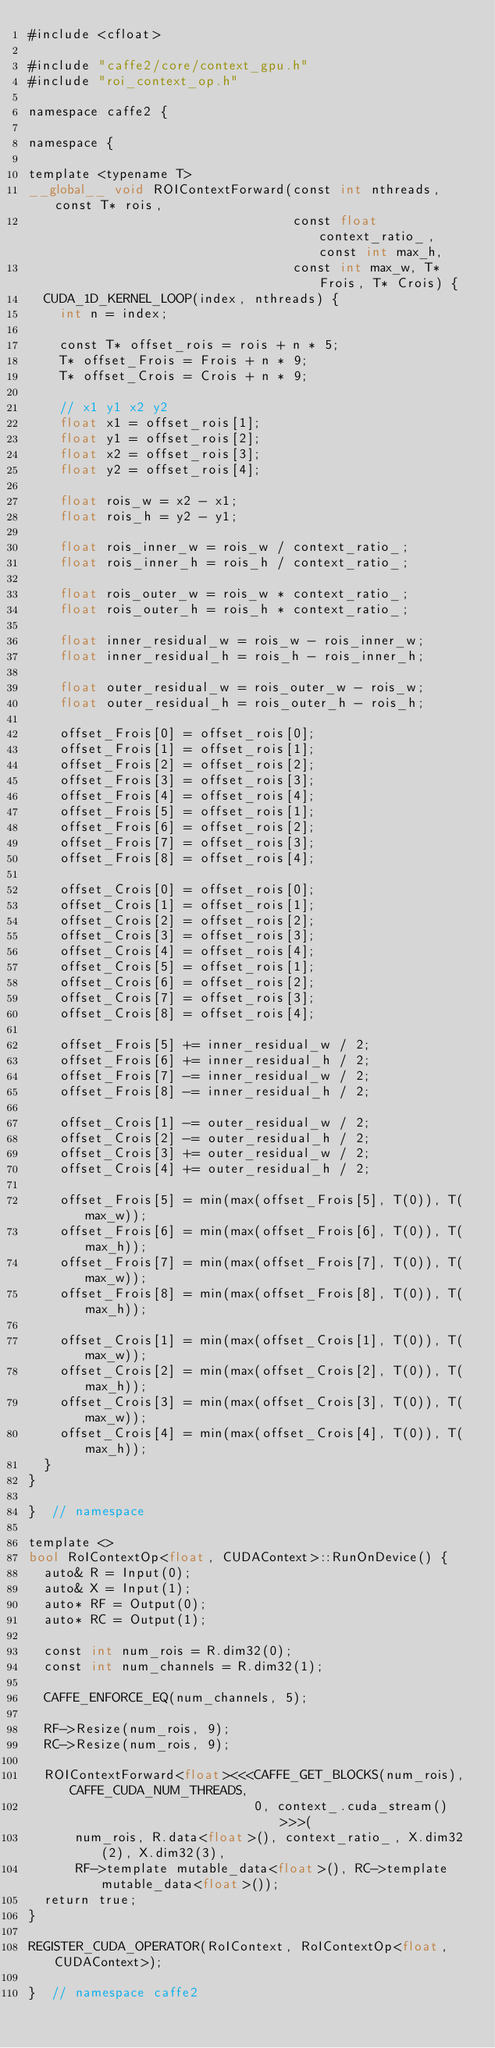Convert code to text. <code><loc_0><loc_0><loc_500><loc_500><_Cuda_>#include <cfloat>

#include "caffe2/core/context_gpu.h"
#include "roi_context_op.h"

namespace caffe2 {

namespace {

template <typename T>
__global__ void ROIContextForward(const int nthreads, const T* rois,
                                  const float context_ratio_, const int max_h,
                                  const int max_w, T* Frois, T* Crois) {
  CUDA_1D_KERNEL_LOOP(index, nthreads) {
    int n = index;

    const T* offset_rois = rois + n * 5;
    T* offset_Frois = Frois + n * 9;
    T* offset_Crois = Crois + n * 9;

    // x1 y1 x2 y2
    float x1 = offset_rois[1];
    float y1 = offset_rois[2];
    float x2 = offset_rois[3];
    float y2 = offset_rois[4];

    float rois_w = x2 - x1;
    float rois_h = y2 - y1;

    float rois_inner_w = rois_w / context_ratio_;
    float rois_inner_h = rois_h / context_ratio_;

    float rois_outer_w = rois_w * context_ratio_;
    float rois_outer_h = rois_h * context_ratio_;

    float inner_residual_w = rois_w - rois_inner_w;
    float inner_residual_h = rois_h - rois_inner_h;

    float outer_residual_w = rois_outer_w - rois_w;
    float outer_residual_h = rois_outer_h - rois_h;

    offset_Frois[0] = offset_rois[0];
    offset_Frois[1] = offset_rois[1];
    offset_Frois[2] = offset_rois[2];
    offset_Frois[3] = offset_rois[3];
    offset_Frois[4] = offset_rois[4];
    offset_Frois[5] = offset_rois[1];
    offset_Frois[6] = offset_rois[2];
    offset_Frois[7] = offset_rois[3];
    offset_Frois[8] = offset_rois[4];

    offset_Crois[0] = offset_rois[0];
    offset_Crois[1] = offset_rois[1];
    offset_Crois[2] = offset_rois[2];
    offset_Crois[3] = offset_rois[3];
    offset_Crois[4] = offset_rois[4];
    offset_Crois[5] = offset_rois[1];
    offset_Crois[6] = offset_rois[2];
    offset_Crois[7] = offset_rois[3];
    offset_Crois[8] = offset_rois[4];

    offset_Frois[5] += inner_residual_w / 2;
    offset_Frois[6] += inner_residual_h / 2;
    offset_Frois[7] -= inner_residual_w / 2;
    offset_Frois[8] -= inner_residual_h / 2;

    offset_Crois[1] -= outer_residual_w / 2;
    offset_Crois[2] -= outer_residual_h / 2;
    offset_Crois[3] += outer_residual_w / 2;
    offset_Crois[4] += outer_residual_h / 2;

    offset_Frois[5] = min(max(offset_Frois[5], T(0)), T(max_w));
    offset_Frois[6] = min(max(offset_Frois[6], T(0)), T(max_h));
    offset_Frois[7] = min(max(offset_Frois[7], T(0)), T(max_w));
    offset_Frois[8] = min(max(offset_Frois[8], T(0)), T(max_h));

    offset_Crois[1] = min(max(offset_Crois[1], T(0)), T(max_w));
    offset_Crois[2] = min(max(offset_Crois[2], T(0)), T(max_h));
    offset_Crois[3] = min(max(offset_Crois[3], T(0)), T(max_w));
    offset_Crois[4] = min(max(offset_Crois[4], T(0)), T(max_h));
  }
}

}  // namespace

template <>
bool RoIContextOp<float, CUDAContext>::RunOnDevice() {
  auto& R = Input(0);
  auto& X = Input(1);
  auto* RF = Output(0);
  auto* RC = Output(1);

  const int num_rois = R.dim32(0);
  const int num_channels = R.dim32(1);

  CAFFE_ENFORCE_EQ(num_channels, 5);

  RF->Resize(num_rois, 9);
  RC->Resize(num_rois, 9);

  ROIContextForward<float><<<CAFFE_GET_BLOCKS(num_rois), CAFFE_CUDA_NUM_THREADS,
                             0, context_.cuda_stream()>>>(
      num_rois, R.data<float>(), context_ratio_, X.dim32(2), X.dim32(3),
      RF->template mutable_data<float>(), RC->template mutable_data<float>());
  return true;
}

REGISTER_CUDA_OPERATOR(RoIContext, RoIContextOp<float, CUDAContext>);

}  // namespace caffe2
</code> 